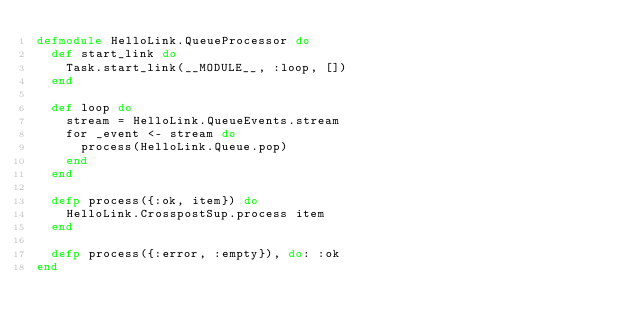Convert code to text. <code><loc_0><loc_0><loc_500><loc_500><_Elixir_>defmodule HelloLink.QueueProcessor do
  def start_link do
    Task.start_link(__MODULE__, :loop, [])
  end

  def loop do
    stream = HelloLink.QueueEvents.stream
    for _event <- stream do
      process(HelloLink.Queue.pop)
    end
  end

  defp process({:ok, item}) do
    HelloLink.CrosspostSup.process item
  end

  defp process({:error, :empty}), do: :ok
end
</code> 